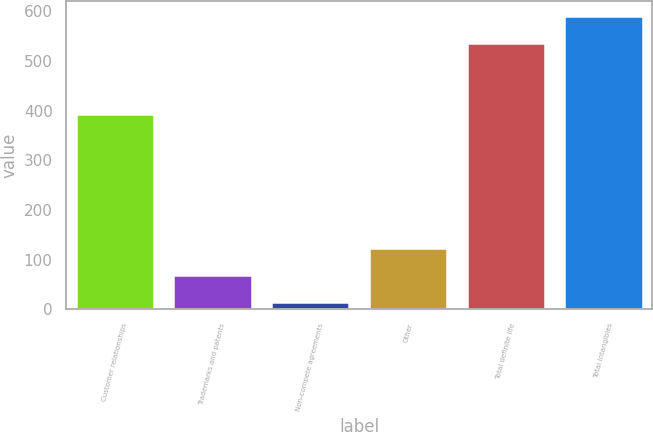Convert chart. <chart><loc_0><loc_0><loc_500><loc_500><bar_chart><fcel>Customer relationships<fcel>Trademarks and patents<fcel>Non-compete agreements<fcel>Other<fcel>Total definite life<fcel>Total intangibles<nl><fcel>393<fcel>68.9<fcel>14<fcel>123.8<fcel>536<fcel>590.9<nl></chart> 